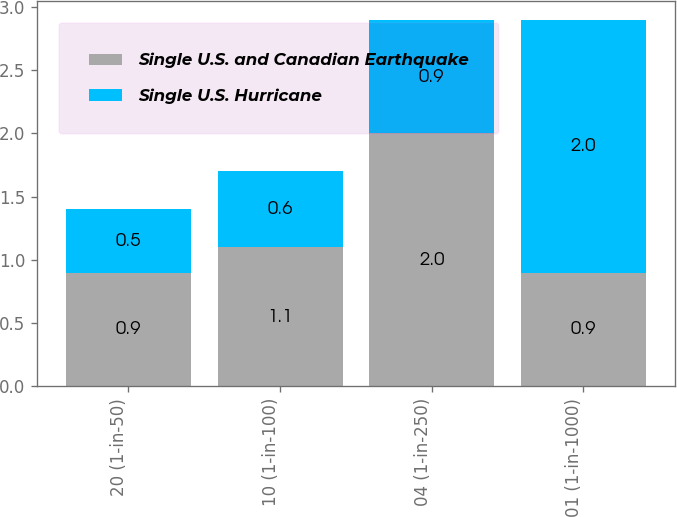<chart> <loc_0><loc_0><loc_500><loc_500><stacked_bar_chart><ecel><fcel>20 (1-in-50)<fcel>10 (1-in-100)<fcel>04 (1-in-250)<fcel>01 (1-in-1000)<nl><fcel>Single U.S. and Canadian Earthquake<fcel>0.9<fcel>1.1<fcel>2<fcel>0.9<nl><fcel>Single U.S. Hurricane<fcel>0.5<fcel>0.6<fcel>0.9<fcel>2<nl></chart> 